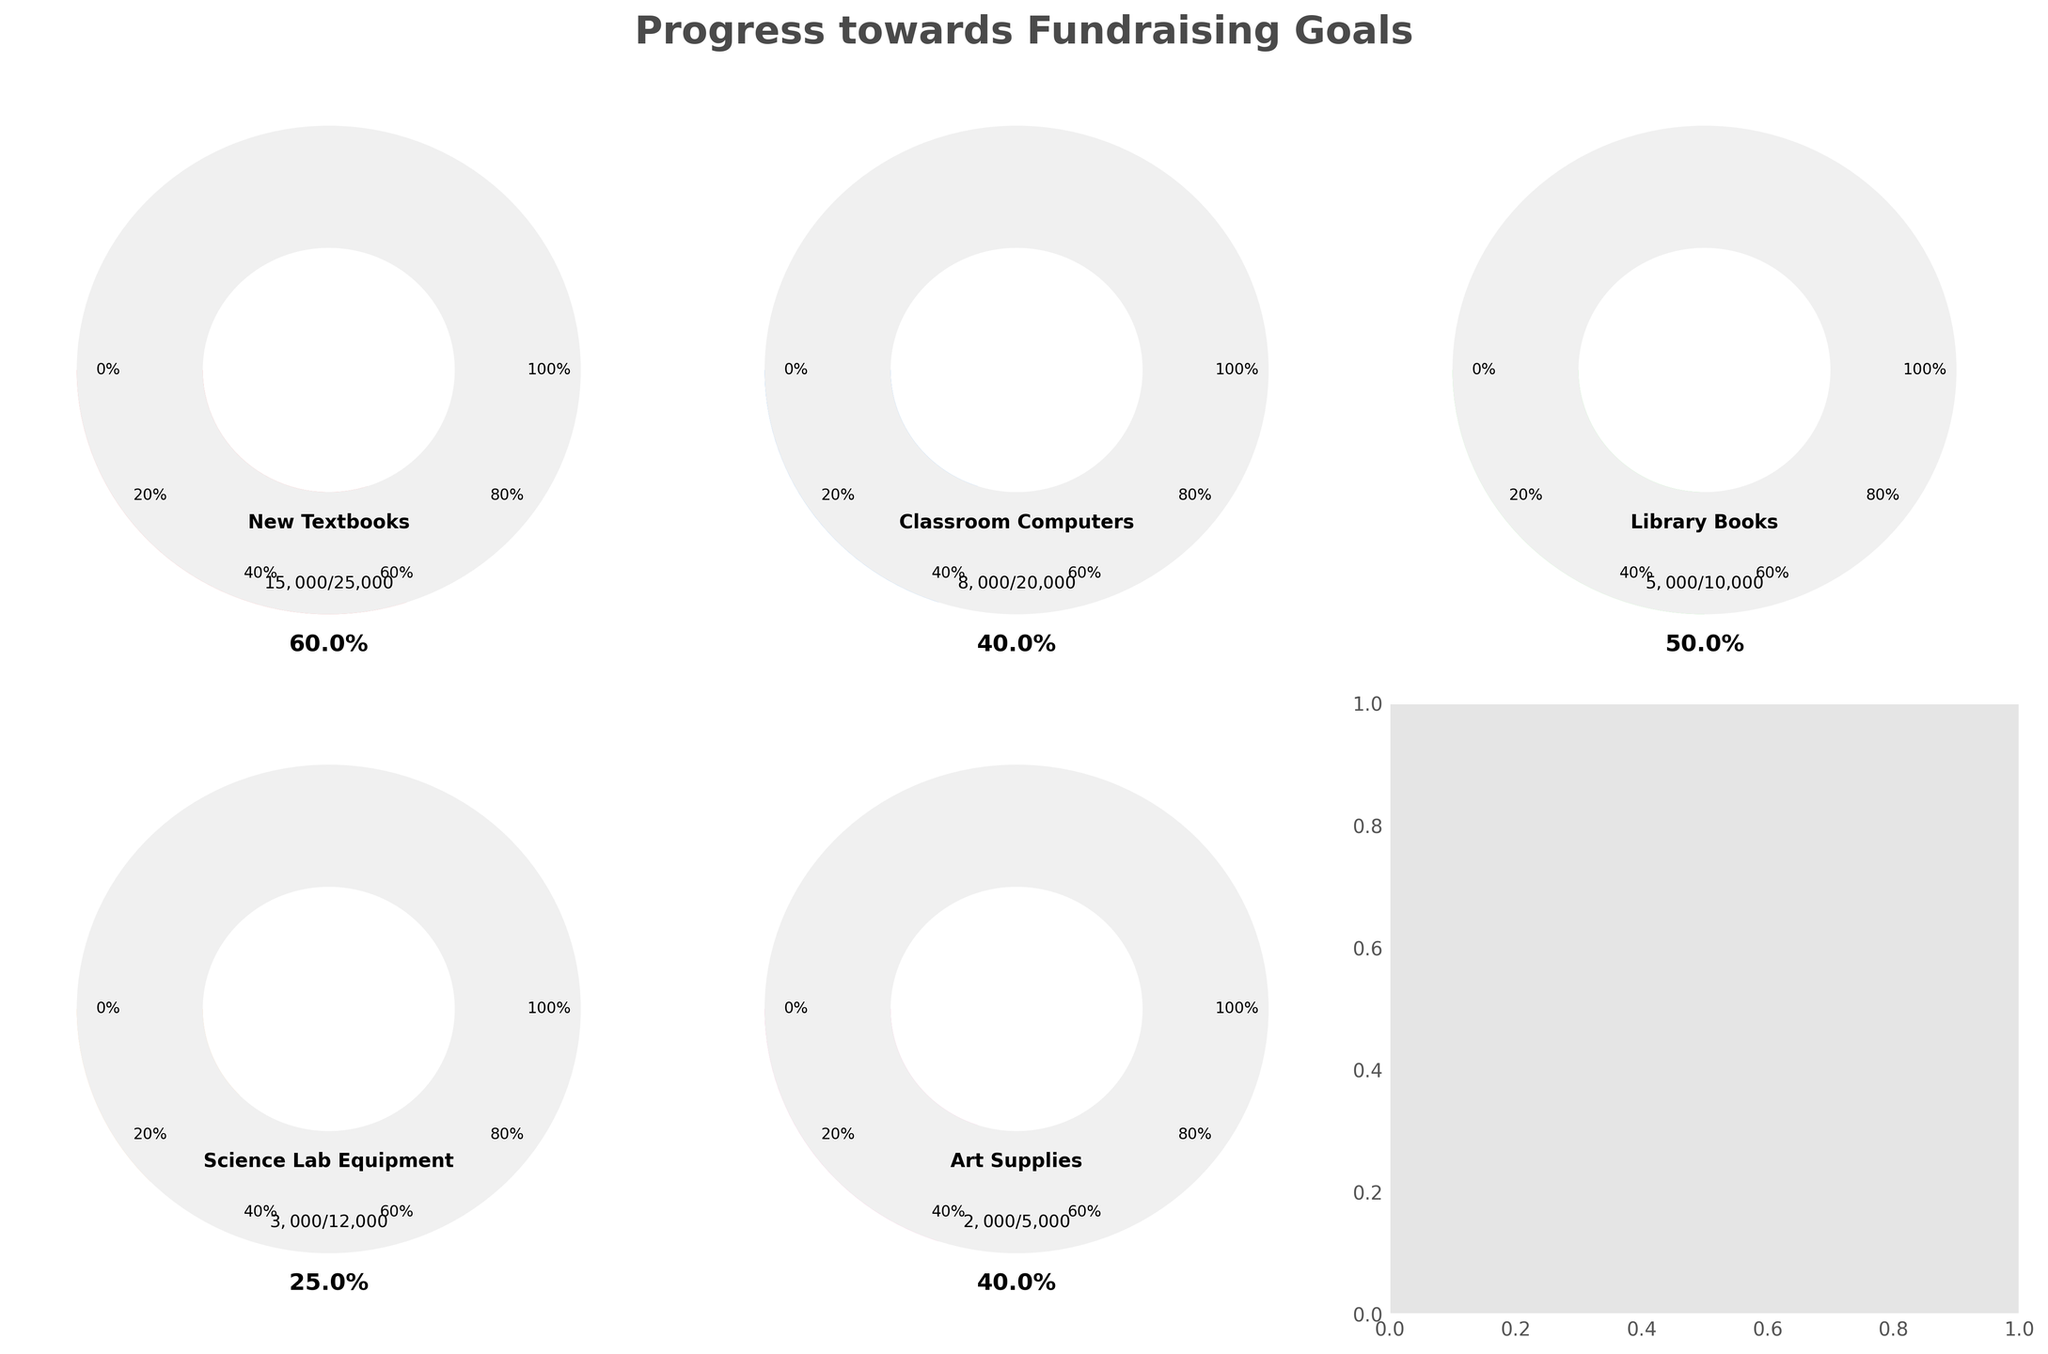What is the title of the figure? The title of the figure is located at the top center and describes the overall purpose of the charts.
Answer: Progress towards Fundraising Goals What are the two goals represented in the top row of the figure? Looking at the top row, the two goals represented can be identified from the labels inside each gauge chart.
Answer: New Textbooks, Classroom Computers How much money has been raised for Classroom Computers? Find the gauge labelled "Classroom Computers" and look at the text indicating the current amount raised.
Answer: $8,000 Which goal has reached 60% completion? Identify the gauge where the progress bar reaches around the 60% mark. This can be verified by checking the specific percentage text within the gauge.
Answer: Science Lab Equipment By how much more is the fundraising goal for New Textbooks compared to Art Supplies? Compare the maximum values for New Textbooks and Art Supplies and find the difference between them.
Answer: $20,000 How many goals have reached at least 50% of their target? Look at each gauge and check if the progress bar has reached or exceeded the 50% mark indicated by the ticks. Count these gauges.
Answer: Three goals What is the total amount currently raised for all the goals combined? Add up the current amounts raised for each goal mentioned within the gauges.
Answer: $33,000 Which goal has the least amount raised so far? Identify the gauge with the lowest current amount raised by comparing the figures mentioned inside each gauge.
Answer: Art Supplies Which goal has the largest gap between the current amount raised and its maximum goal? Calculate the difference between the current and maximum amounts for each goal and identify the goal with the largest difference.
Answer: Classroom Computers Which goal's fundraising progress is depicted in pink? Identify the color used for each gauge and find the one represented by pink.
Answer: New Textbooks 